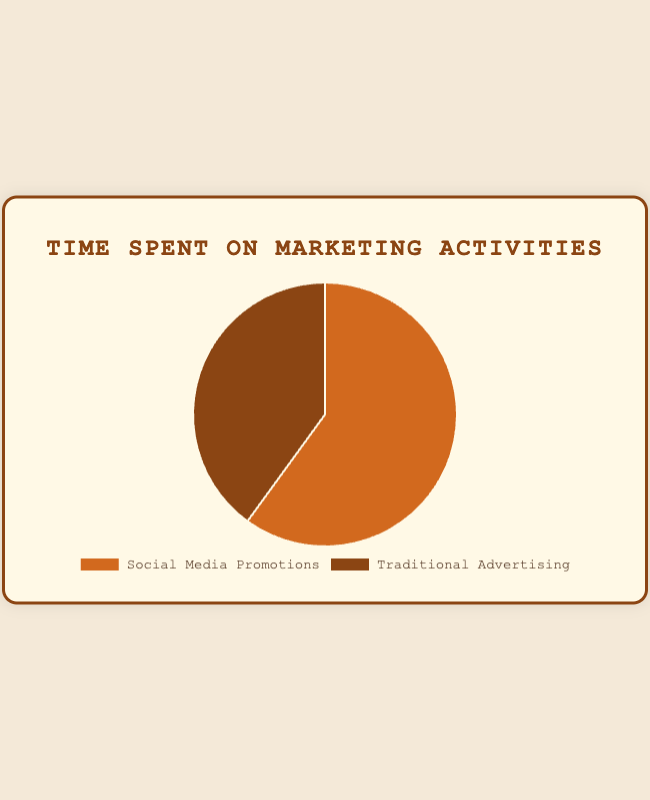What percentage of time is spent on social media promotions? The pie chart shows two segments with percentages. The social media promotions segment is labeled "Social Media Promotions" and accounts for 60% of the total time.
Answer: 60% What percentage of time is spent on traditional advertising? Observing the pie chart, the traditional advertising segment is labeled "Traditional Advertising" and shows a percentage of 40%.
Answer: 40% Which marketing activity takes more time, social media promotions or traditional advertising? Comparing the two segments' sizes and percentages, social media promotions take 60%, which is greater than traditional advertising's 40%.
Answer: Social media promotions By what percentage is the time spent on social media promotions greater than the time spent on traditional advertising? The time spent on social media promotions is 60%, while traditional advertising accounts for 40%. Subtracting these percentages: 60% - 40% = 20%.
Answer: 20% If the total time spent on marketing activities is 100 hours, how many hours are spent on social media promotions? Given that 60% of the time is on social media promotions, calculate 60% of 100 hours: (60/100) * 100 = 60 hours.
Answer: 60 hours Which segment in the pie chart is larger in terms of visual size and what does it represent? Observing the pie chart, the "Social Media Promotions" segment appears larger and represents a higher percentage, which is 60%.
Answer: Social Media Promotions What is the ratio of time spent on social media promotions to traditional advertising? The pie chart shows social media promotions at 60% and traditional advertising at 40%. The ratio is 60:40 or simplified to 3:2.
Answer: 3:2 Is the time spent on traditional advertising less than half of the total marketing time? Traditional advertising is 40% of the total marketing time, which is less than half, as half would be 50%.
Answer: Yes If you wanted to balance the time spent equally between social media promotions and traditional advertising, by how much should the time spent on social media promotions be reduced? To balance time at 50% for each activity, reduce social media promotions from 60% to 50%. The reduction needed is: 60% - 50% = 10%.
Answer: 10% reduction 